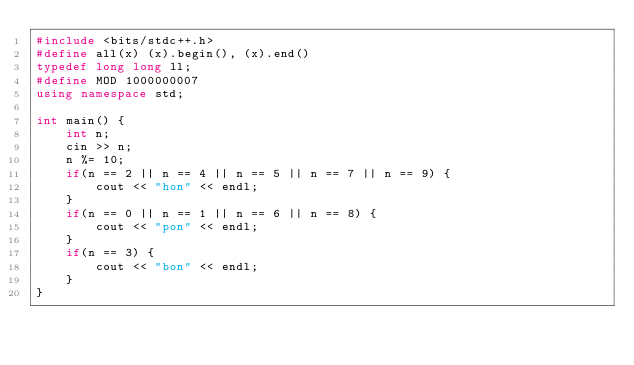<code> <loc_0><loc_0><loc_500><loc_500><_C++_>#include <bits/stdc++.h>
#define all(x) (x).begin(), (x).end()
typedef long long ll;
#define MOD 1000000007
using namespace std;

int main() {
    int n;
    cin >> n;
    n %= 10;
    if(n == 2 || n == 4 || n == 5 || n == 7 || n == 9) {
        cout << "hon" << endl;
    }
    if(n == 0 || n == 1 || n == 6 || n == 8) {
        cout << "pon" << endl;
    }
    if(n == 3) {
        cout << "bon" << endl;
    }
}
</code> 